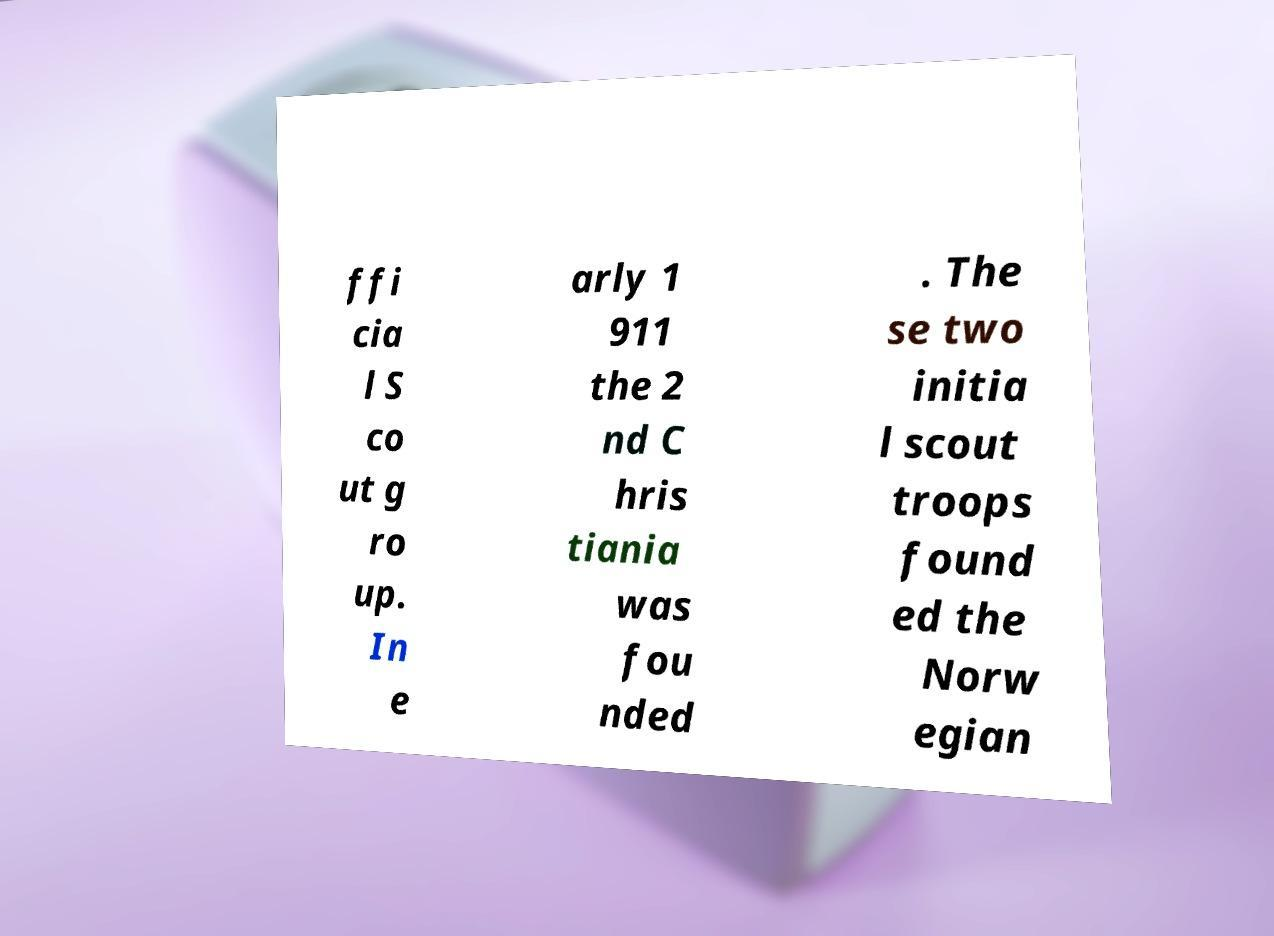Could you assist in decoding the text presented in this image and type it out clearly? ffi cia l S co ut g ro up. In e arly 1 911 the 2 nd C hris tiania was fou nded . The se two initia l scout troops found ed the Norw egian 